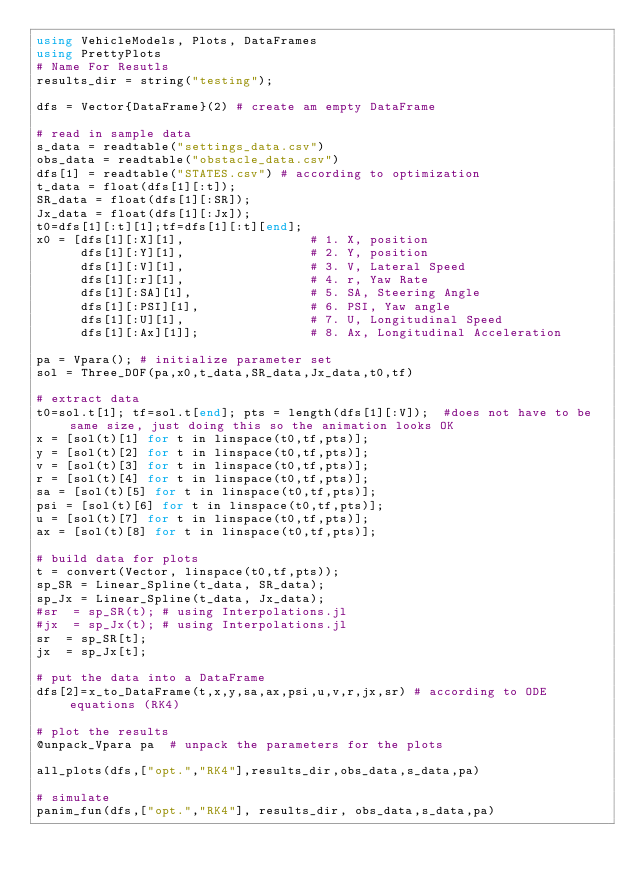Convert code to text. <code><loc_0><loc_0><loc_500><loc_500><_Julia_>using VehicleModels, Plots, DataFrames
using PrettyPlots
# Name For Resutls
results_dir = string("testing");

dfs = Vector{DataFrame}(2) # create am empty DataFrame

# read in sample data
s_data = readtable("settings_data.csv")
obs_data = readtable("obstacle_data.csv")
dfs[1] = readtable("STATES.csv") # according to optimization
t_data = float(dfs[1][:t]);
SR_data = float(dfs[1][:SR]);
Jx_data = float(dfs[1][:Jx]);
t0=dfs[1][:t][1];tf=dfs[1][:t][end];
x0 = [dfs[1][:X][1],                 # 1. X, position
      dfs[1][:Y][1],                 # 2. Y, position
      dfs[1][:V][1],                 # 3. V, Lateral Speed
      dfs[1][:r][1],                 # 4. r, Yaw Rate
      dfs[1][:SA][1],                # 5. SA, Steering Angle
      dfs[1][:PSI][1],               # 6. PSI, Yaw angle
      dfs[1][:U][1],                 # 7. U, Longitudinal Speed
      dfs[1][:Ax][1]];               # 8. Ax, Longitudinal Acceleration

pa = Vpara(); # initialize parameter set
sol = Three_DOF(pa,x0,t_data,SR_data,Jx_data,t0,tf)

# extract data
t0=sol.t[1]; tf=sol.t[end]; pts = length(dfs[1][:V]);  #does not have to be same size, just doing this so the animation looks OK
x = [sol(t)[1] for t in linspace(t0,tf,pts)];
y = [sol(t)[2] for t in linspace(t0,tf,pts)];
v = [sol(t)[3] for t in linspace(t0,tf,pts)];
r = [sol(t)[4] for t in linspace(t0,tf,pts)];
sa = [sol(t)[5] for t in linspace(t0,tf,pts)];
psi = [sol(t)[6] for t in linspace(t0,tf,pts)];
u = [sol(t)[7] for t in linspace(t0,tf,pts)];
ax = [sol(t)[8] for t in linspace(t0,tf,pts)];

# build data for plots
t = convert(Vector, linspace(t0,tf,pts));
sp_SR = Linear_Spline(t_data, SR_data);
sp_Jx = Linear_Spline(t_data, Jx_data);
#sr  = sp_SR(t); # using Interpolations.jl
#jx  = sp_Jx(t); # using Interpolations.jl
sr  = sp_SR[t];
jx  = sp_Jx[t];

# put the data into a DataFrame
dfs[2]=x_to_DataFrame(t,x,y,sa,ax,psi,u,v,r,jx,sr) # according to ODE equations (RK4)

# plot the results
@unpack_Vpara pa  # unpack the parameters for the plots

all_plots(dfs,["opt.","RK4"],results_dir,obs_data,s_data,pa)

# simulate
panim_fun(dfs,["opt.","RK4"], results_dir, obs_data,s_data,pa)
</code> 